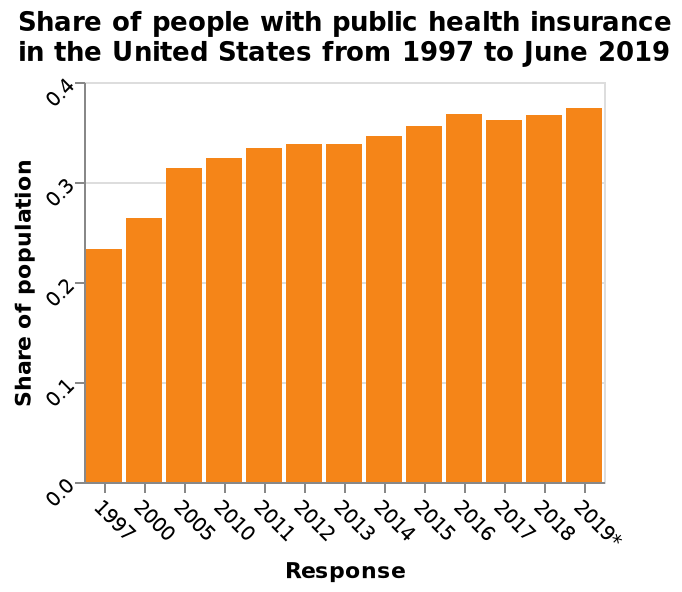<image>
What is the time range covered in the bar graph? The time range covered in the bar graph is from 1997 to June 2019. 